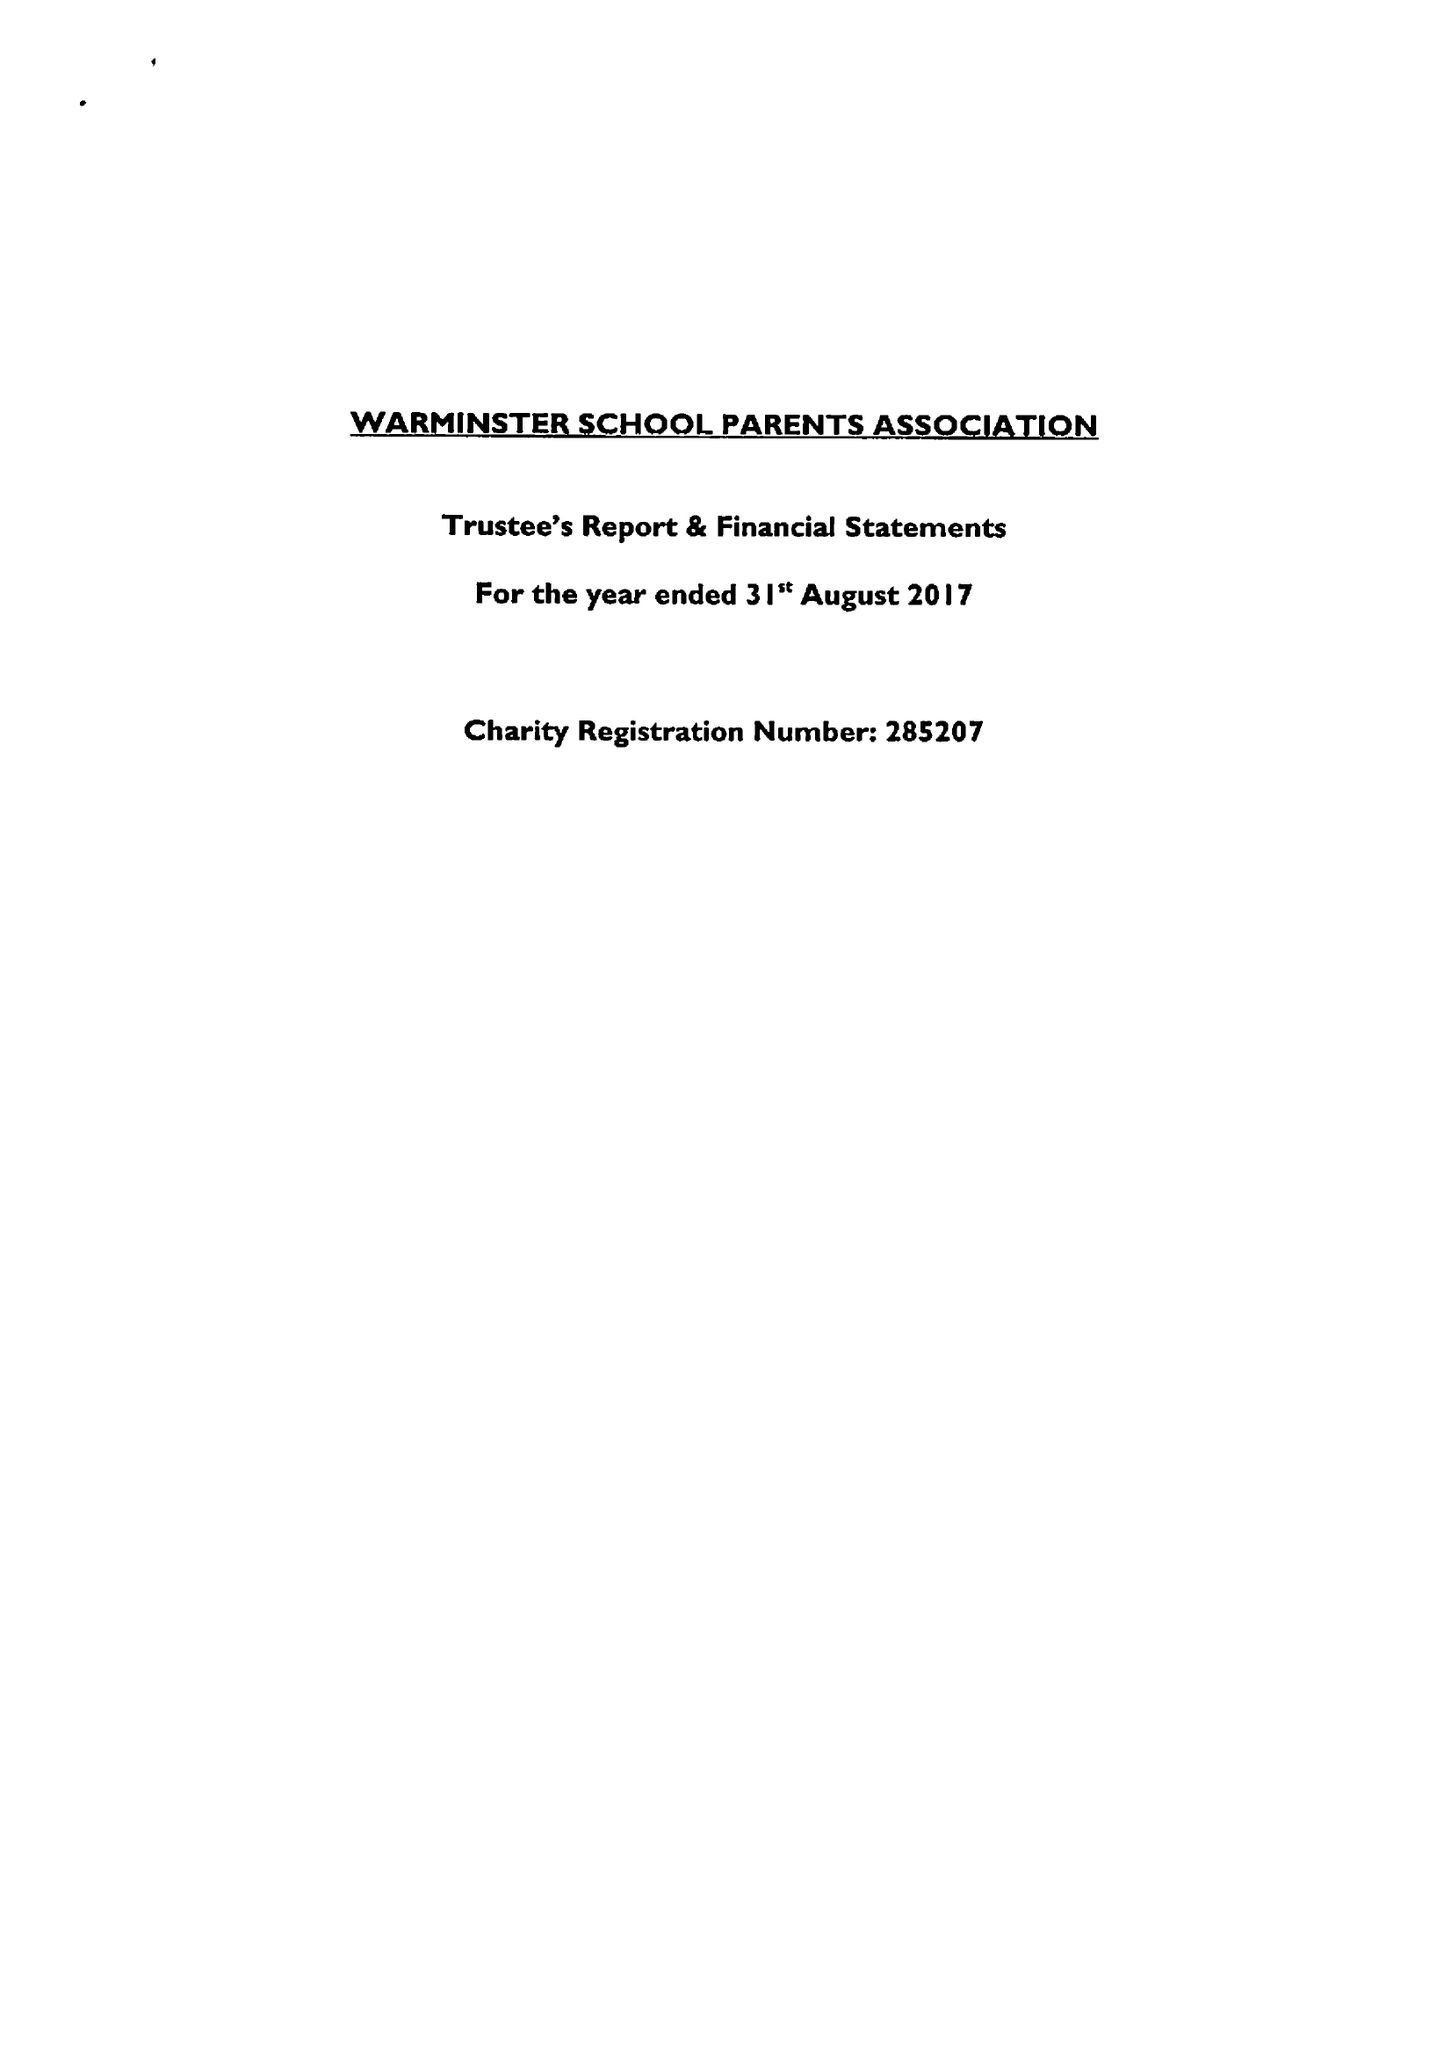What is the value for the charity_number?
Answer the question using a single word or phrase. 285207 